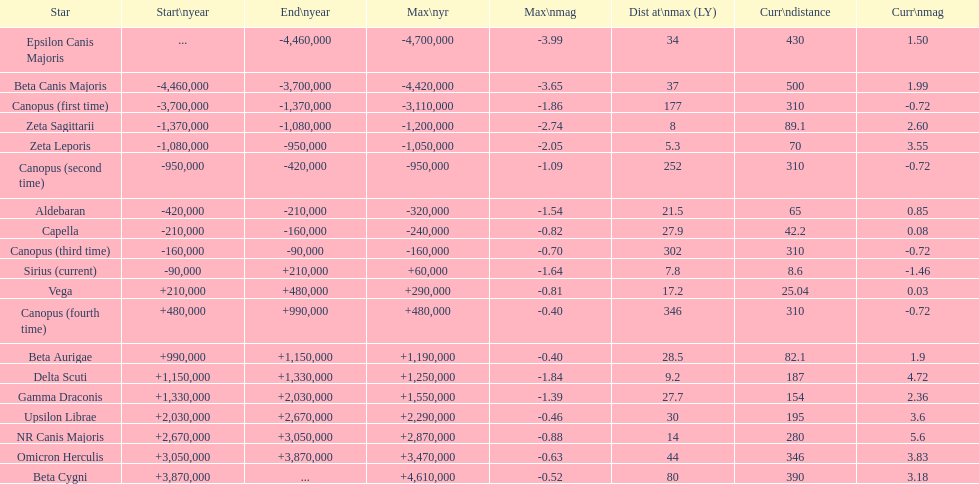What is the number of stars that have a maximum magnitude less than zero? 5. 